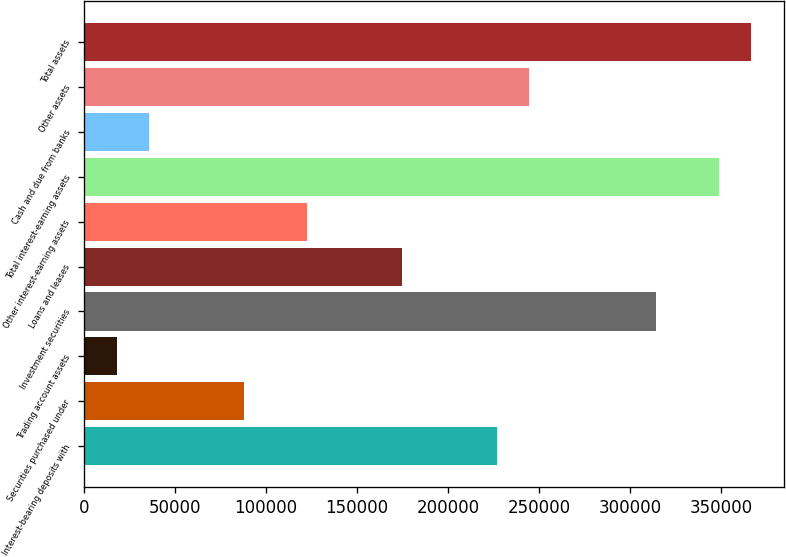Convert chart. <chart><loc_0><loc_0><loc_500><loc_500><bar_chart><fcel>Interest-bearing deposits with<fcel>Securities purchased under<fcel>Trading account assets<fcel>Investment securities<fcel>Loans and leases<fcel>Other interest-earning assets<fcel>Total interest-earning assets<fcel>Cash and due from banks<fcel>Other assets<fcel>Total assets<nl><fcel>226932<fcel>87801.5<fcel>18236.3<fcel>313888<fcel>174758<fcel>122584<fcel>348671<fcel>35627.6<fcel>244323<fcel>366062<nl></chart> 